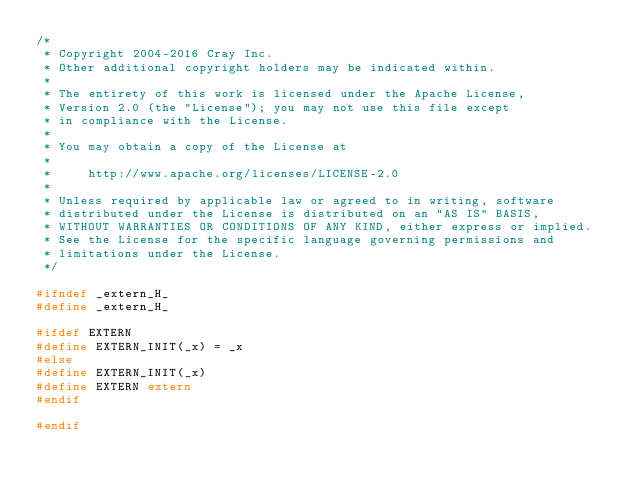<code> <loc_0><loc_0><loc_500><loc_500><_C_>/*
 * Copyright 2004-2016 Cray Inc.
 * Other additional copyright holders may be indicated within.
 * 
 * The entirety of this work is licensed under the Apache License,
 * Version 2.0 (the "License"); you may not use this file except
 * in compliance with the License.
 * 
 * You may obtain a copy of the License at
 * 
 *     http://www.apache.org/licenses/LICENSE-2.0
 * 
 * Unless required by applicable law or agreed to in writing, software
 * distributed under the License is distributed on an "AS IS" BASIS,
 * WITHOUT WARRANTIES OR CONDITIONS OF ANY KIND, either express or implied.
 * See the License for the specific language governing permissions and
 * limitations under the License.
 */

#ifndef _extern_H_
#define _extern_H_

#ifdef EXTERN
#define EXTERN_INIT(_x) = _x
#else
#define EXTERN_INIT(_x)
#define EXTERN extern
#endif

#endif

</code> 